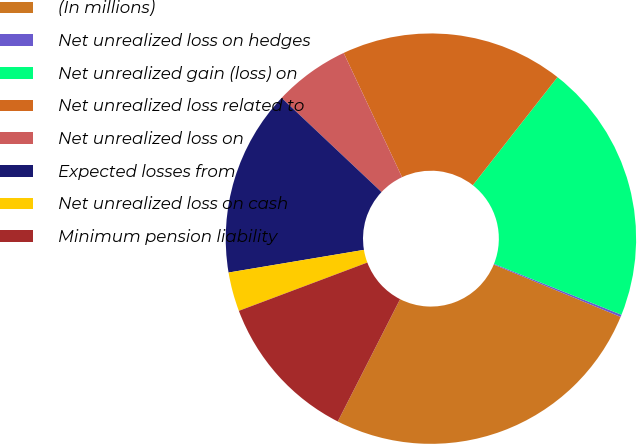<chart> <loc_0><loc_0><loc_500><loc_500><pie_chart><fcel>(In millions)<fcel>Net unrealized loss on hedges<fcel>Net unrealized gain (loss) on<fcel>Net unrealized loss related to<fcel>Net unrealized loss on<fcel>Expected losses from<fcel>Net unrealized loss on cash<fcel>Minimum pension liability<nl><fcel>26.27%<fcel>0.18%<fcel>20.47%<fcel>17.57%<fcel>5.98%<fcel>14.67%<fcel>3.08%<fcel>11.78%<nl></chart> 